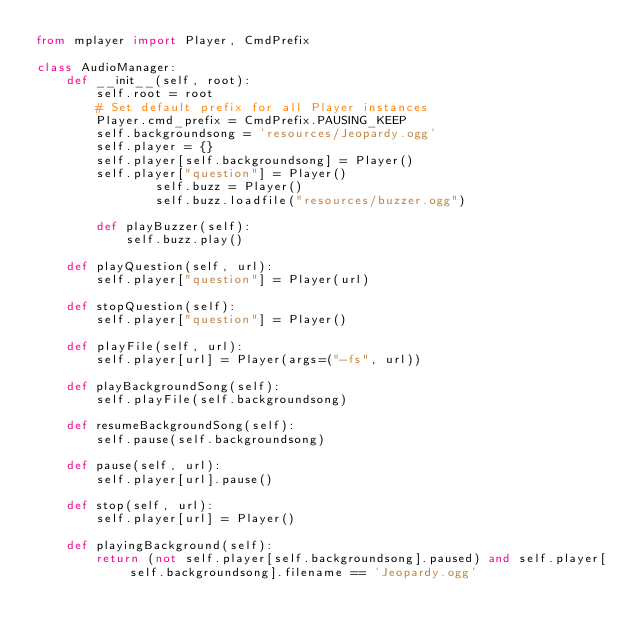<code> <loc_0><loc_0><loc_500><loc_500><_Python_>from mplayer import Player, CmdPrefix

class AudioManager:
	def __init__(self, root):
		self.root = root
		# Set default prefix for all Player instances
		Player.cmd_prefix = CmdPrefix.PAUSING_KEEP
		self.backgroundsong = 'resources/Jeopardy.ogg'
		self.player = {}
		self.player[self.backgroundsong] = Player()
		self.player["question"]	= Player()
                self.buzz = Player()
                self.buzz.loadfile("resources/buzzer.ogg")

        def playBuzzer(self):
            self.buzz.play()

	def playQuestion(self, url):
		self.player["question"] = Player(url)

	def stopQuestion(self):
		self.player["question"] = Player()

	def playFile(self, url):
		self.player[url] = Player(args=("-fs", url))

	def playBackgroundSong(self):
		self.playFile(self.backgroundsong)

	def resumeBackgroundSong(self):
		self.pause(self.backgroundsong)

	def pause(self, url):
		self.player[url].pause()

	def stop(self, url):
		self.player[url] = Player()

	def playingBackground(self):
		return (not self.player[self.backgroundsong].paused) and self.player[self.backgroundsong].filename == 'Jeopardy.ogg'
</code> 